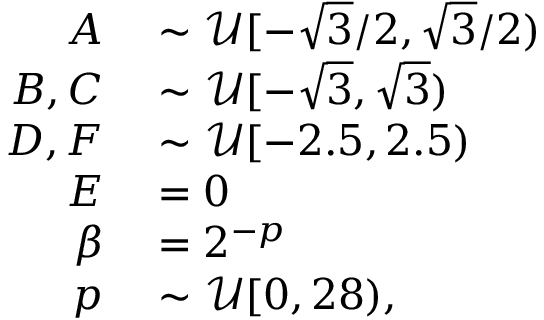<formula> <loc_0><loc_0><loc_500><loc_500>\begin{array} { r l } { A } & \sim \mathcal { U } [ - \sqrt { 3 } / 2 , \sqrt { 3 } / 2 ) } \\ { B , C } & \sim \mathcal { U } [ - \sqrt { 3 } , \sqrt { 3 } ) } \\ { D , F } & \sim \mathcal { U } [ - 2 . 5 , 2 . 5 ) } \\ { E } & = 0 } \\ { \beta } & = 2 ^ { - p } } \\ { p } & \sim \mathcal { U } [ 0 , 2 8 ) , } \end{array}</formula> 